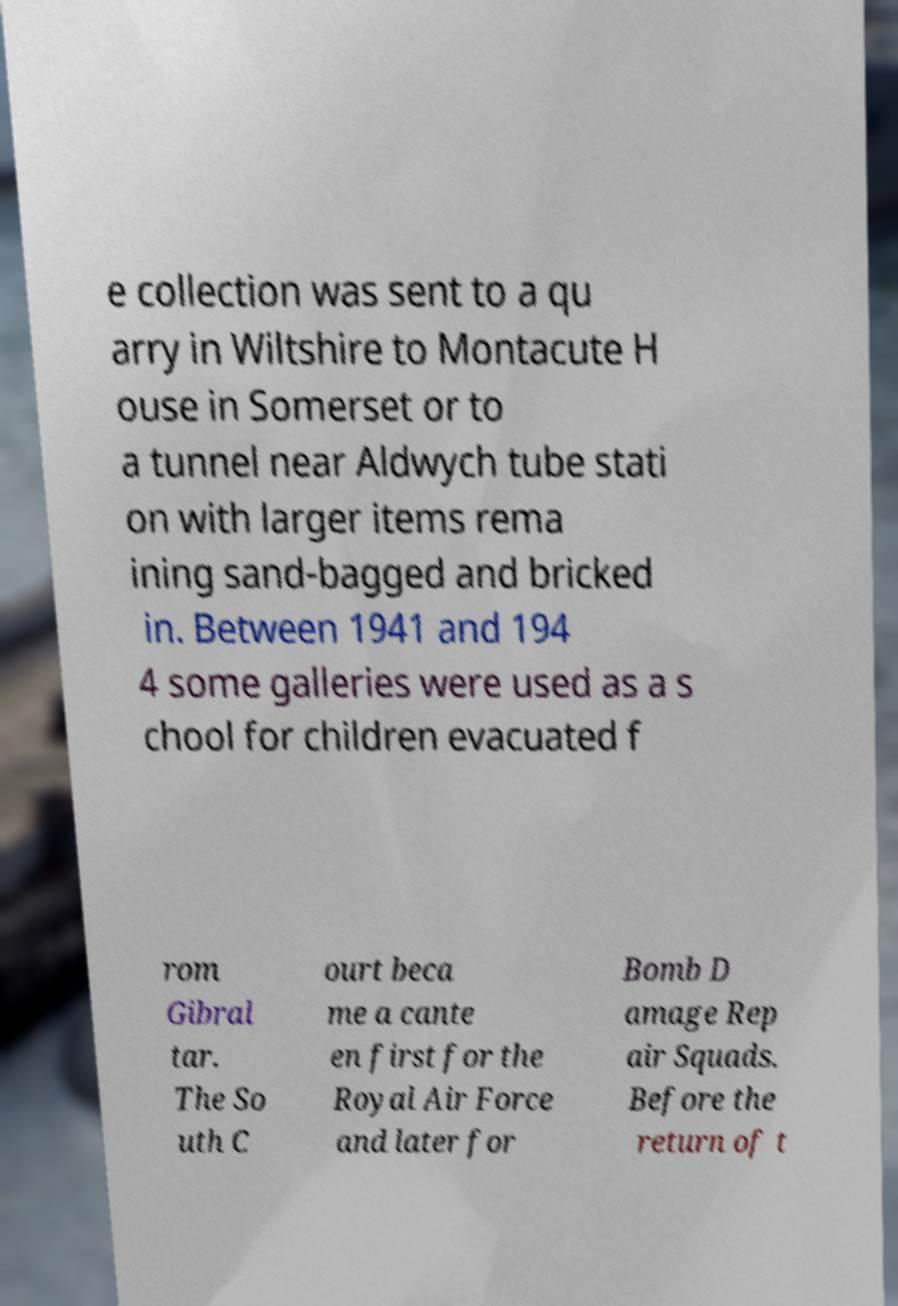For documentation purposes, I need the text within this image transcribed. Could you provide that? e collection was sent to a qu arry in Wiltshire to Montacute H ouse in Somerset or to a tunnel near Aldwych tube stati on with larger items rema ining sand-bagged and bricked in. Between 1941 and 194 4 some galleries were used as a s chool for children evacuated f rom Gibral tar. The So uth C ourt beca me a cante en first for the Royal Air Force and later for Bomb D amage Rep air Squads. Before the return of t 